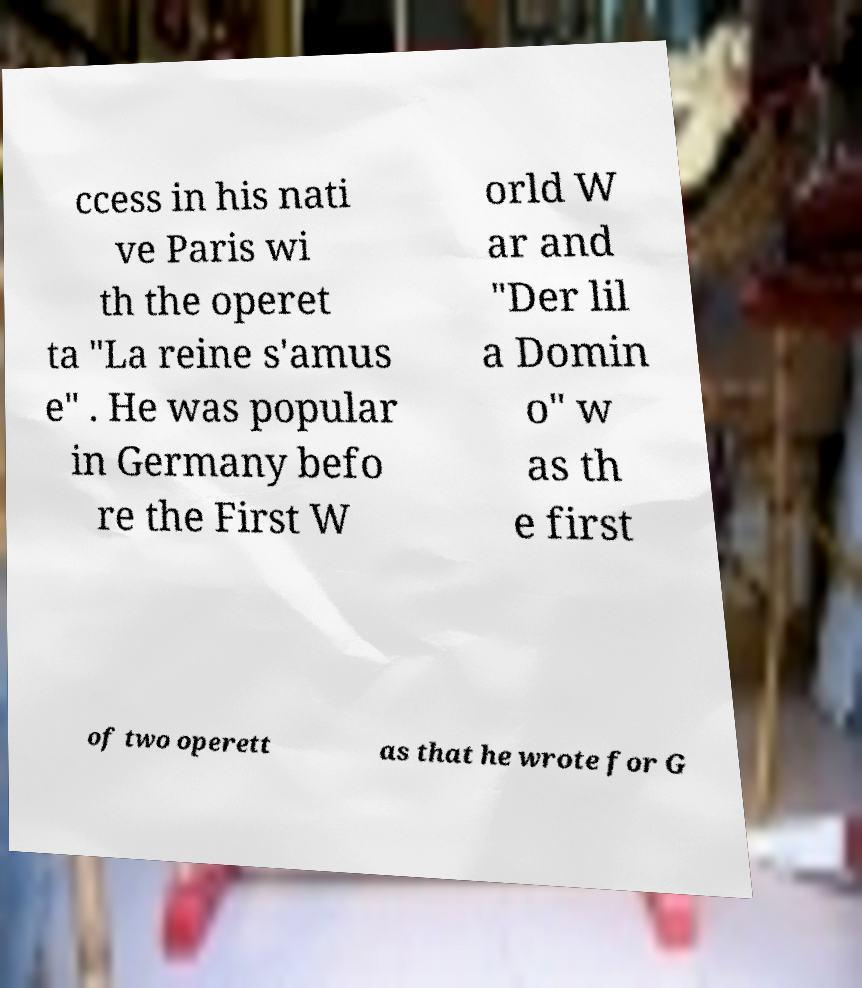Could you assist in decoding the text presented in this image and type it out clearly? ccess in his nati ve Paris wi th the operet ta "La reine s'amus e" . He was popular in Germany befo re the First W orld W ar and "Der lil a Domin o" w as th e first of two operett as that he wrote for G 